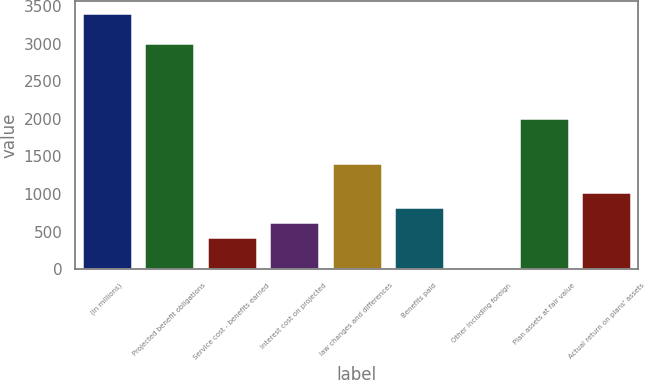Convert chart to OTSL. <chart><loc_0><loc_0><loc_500><loc_500><bar_chart><fcel>(in millions)<fcel>Projected benefit obligations<fcel>Service cost - benefits earned<fcel>Interest cost on projected<fcel>law changes and differences<fcel>Benefits paid<fcel>Other including foreign<fcel>Plan assets at fair value<fcel>Actual return on plans' assets<nl><fcel>3402.5<fcel>3005.5<fcel>425<fcel>623.5<fcel>1417.5<fcel>822<fcel>28<fcel>2013<fcel>1020.5<nl></chart> 